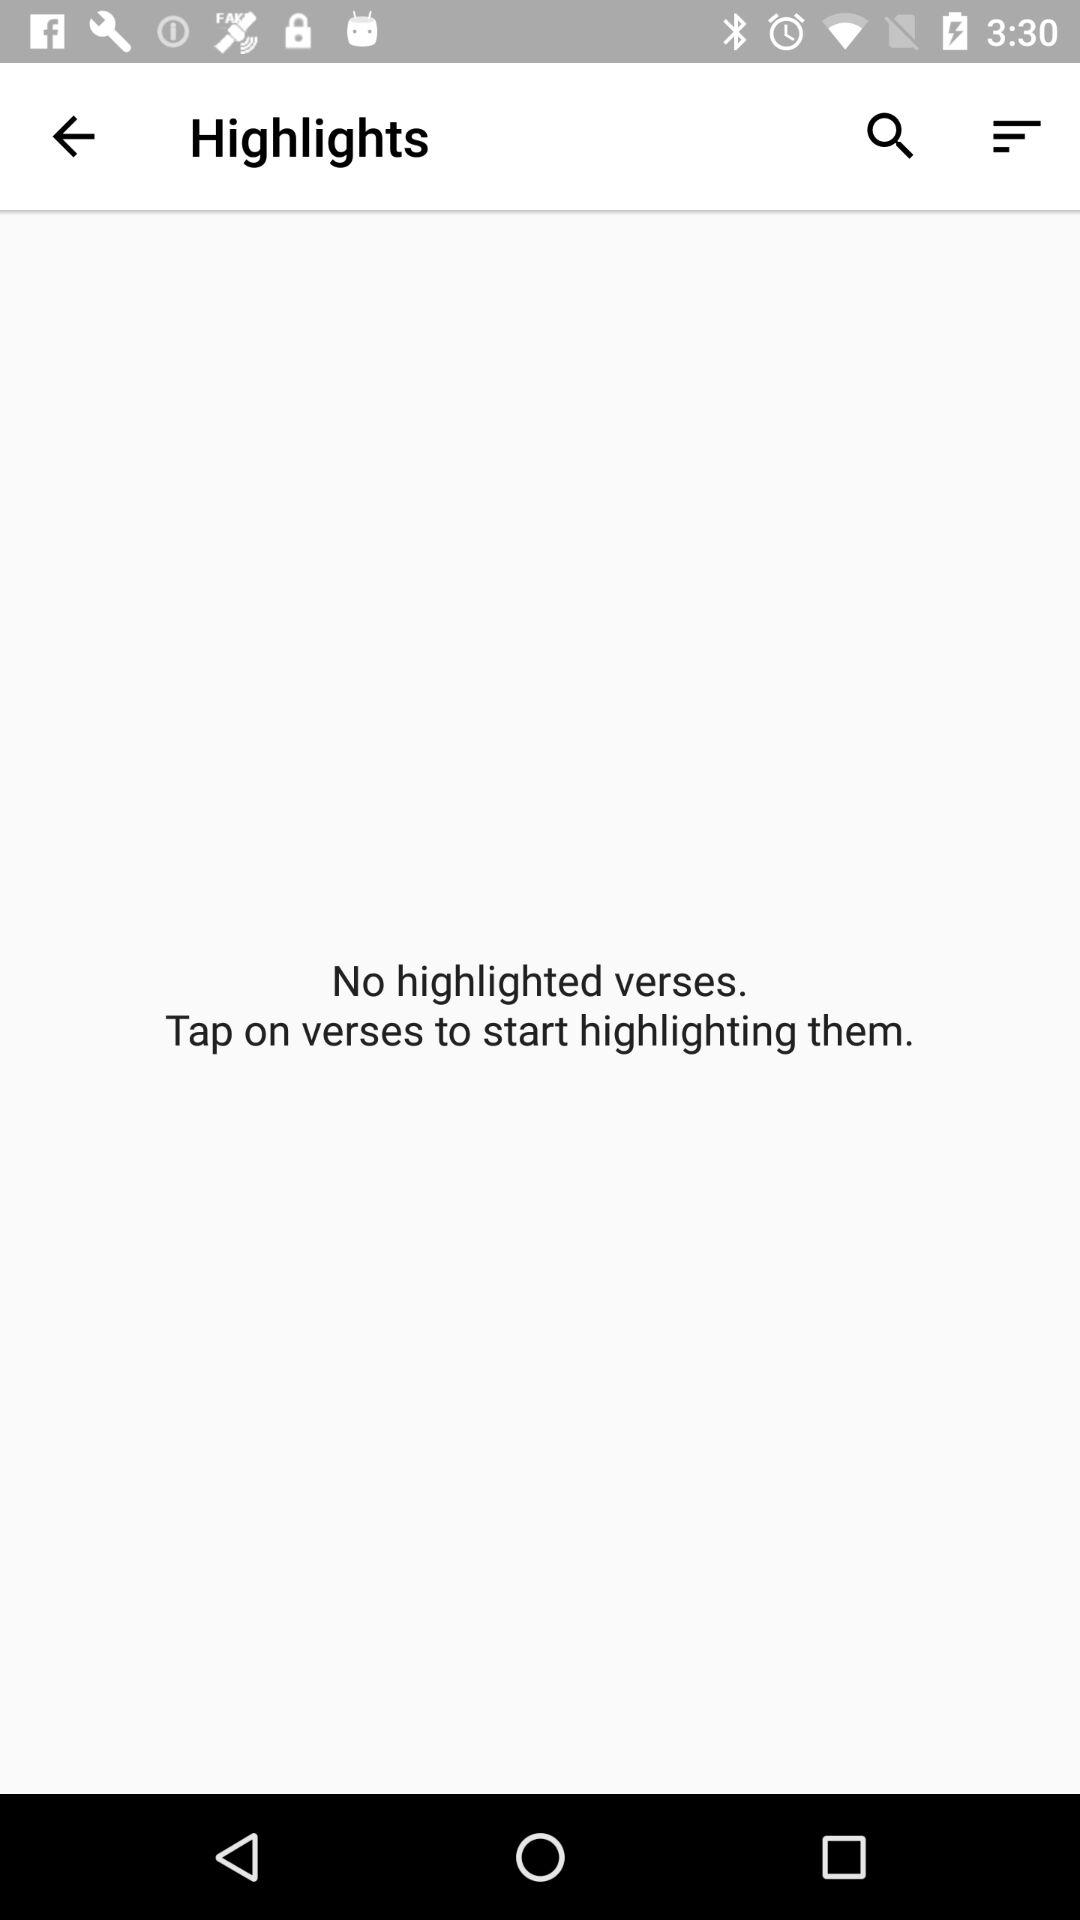How many verses are highlighted?
Answer the question using a single word or phrase. 0 